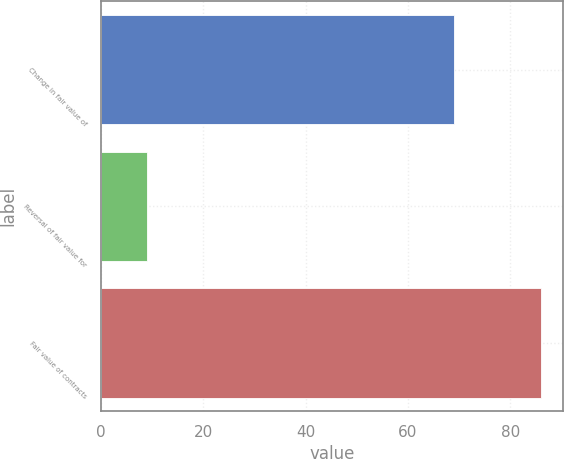Convert chart. <chart><loc_0><loc_0><loc_500><loc_500><bar_chart><fcel>Change in fair value of<fcel>Reversal of fair value for<fcel>Fair value of contracts<nl><fcel>69<fcel>9<fcel>86<nl></chart> 